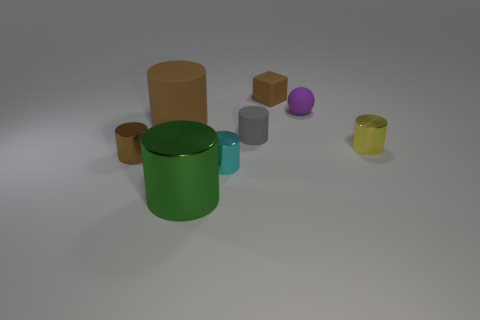Do the small ball and the rubber thing that is to the left of the gray rubber thing have the same color?
Provide a succinct answer. No. What is the cyan cylinder made of?
Keep it short and to the point. Metal. The shiny thing that is on the right side of the small brown cube is what color?
Your answer should be very brief. Yellow. What number of big rubber cylinders have the same color as the tiny matte block?
Your answer should be very brief. 1. What number of brown objects are behind the small gray matte object and in front of the small rubber cube?
Provide a short and direct response. 1. What shape is the gray rubber thing that is the same size as the brown matte cube?
Offer a very short reply. Cylinder. What size is the yellow thing?
Provide a short and direct response. Small. There is a small brown thing that is in front of the rubber cylinder that is to the right of the large cylinder in front of the small gray matte thing; what is it made of?
Your answer should be very brief. Metal. What is the color of the other cylinder that is made of the same material as the big brown cylinder?
Keep it short and to the point. Gray. There is a rubber thing to the right of the brown thing that is behind the small purple sphere; what number of brown objects are behind it?
Provide a short and direct response. 1. 